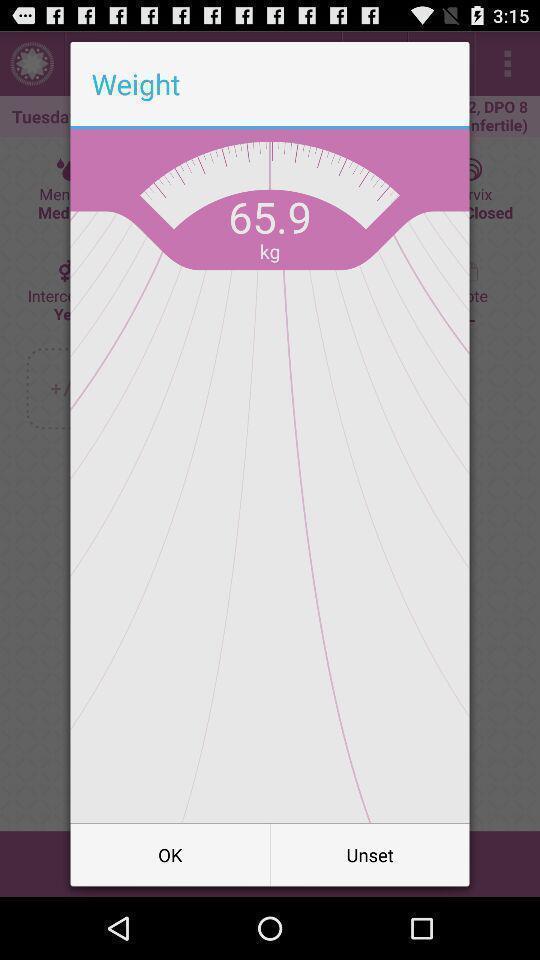Give me a narrative description of this picture. Popup displaying weight information. 